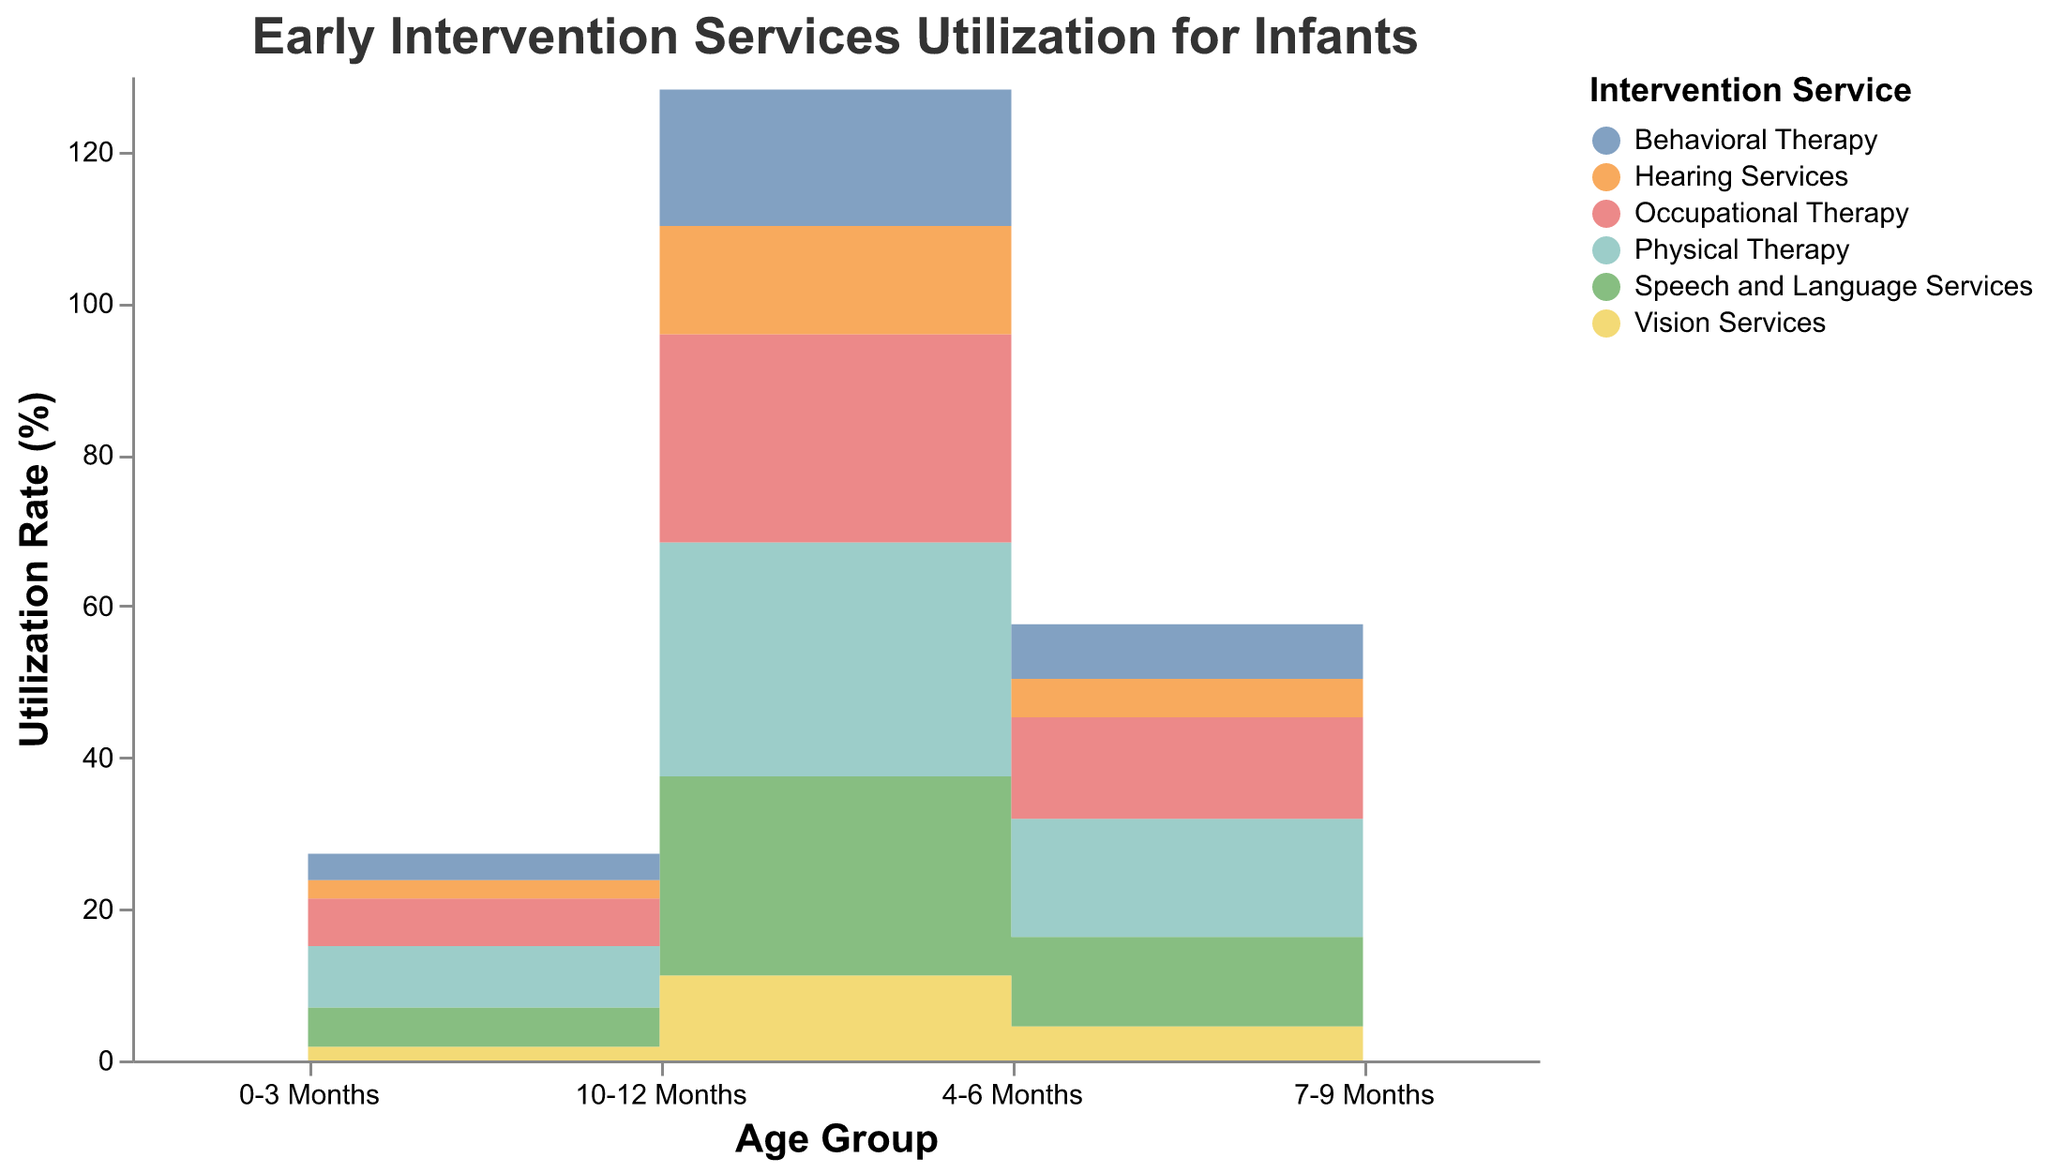What is the utilization rate of Speech and Language Services for infants aged 7-9 months? The utilization rate for Speech and Language Services in the 7-9 months age group is given directly by the data for that age group.
Answer: 18.5% Which early intervention service has the highest utilization rate in the 10-12 months age group? Compare the rates of all services in the 10-12 months group. Physical Therapy has the highest rate at 30.9%.
Answer: Physical Therapy How does the utilization rate of Occupational Therapy change from the 0-3 months group to the 10-12 months group? Subtract the rate of Occupational Therapy in the 0-3 months group from the 10-12 months group rate (27.5 - 6.3).
Answer: It increases by 21.2% Which service shows the largest increase in utilization rate from the 4-6 months group to the 7-9 months group? Calculate the difference in utilization rates for all services between the two age groups. Find the largest value. Behavioral Therapy increases by 4.4 (11.6 - 7.2).
Answer: Behavioral Therapy What is the total utilization rate for all services combined in the 0-3 months age group? Sum up the rates for all services in the 0-3 months group: 5.2 + 8.1 + 6.3 + 3.5 + 1.8 + 2.4.
Answer: 27.3% By how much does the rate of Vision Services increase from the 4-6 months group to the 10-12 months group? Subtract the rate of Vision Services in the 4-6 months group from the 10-12 months group rate (11.2 - 4.5).
Answer: 6.7% Which early intervention service has the lowest utilization rate in the 7-9 months age group? Compare the rates of all services in the 7-9 months age group. Vision Services have the lowest rate at 7.3%.
Answer: Vision Services What is the average utilization rate of Physical Therapy across all age groups? Sum the rates of Physical Therapy across all age groups and divide by the number of age groups (8.1 + 15.6 + 22.4 + 30.9) / 4.
Answer: 19.25% How does the trend of utilization rates of Hearing Services compare to that of Speech and Language Services across the age groups? Chart-Type Specific: Assess the slopes and differences for each age group for both services. Both show a consistent upward trend, but Speech and Language Services typically have lower rates than Physical Therapy.
Answer: Both show consistent increases, but rates for Physical Therapy are generally higher 